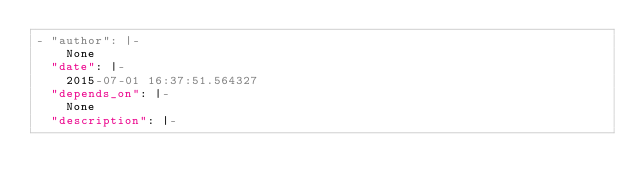Convert code to text. <code><loc_0><loc_0><loc_500><loc_500><_YAML_>- "author": |-
    None
  "date": |-
    2015-07-01 16:37:51.564327
  "depends_on": |-
    None
  "description": |-</code> 